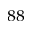<formula> <loc_0><loc_0><loc_500><loc_500>^ { 8 8 }</formula> 